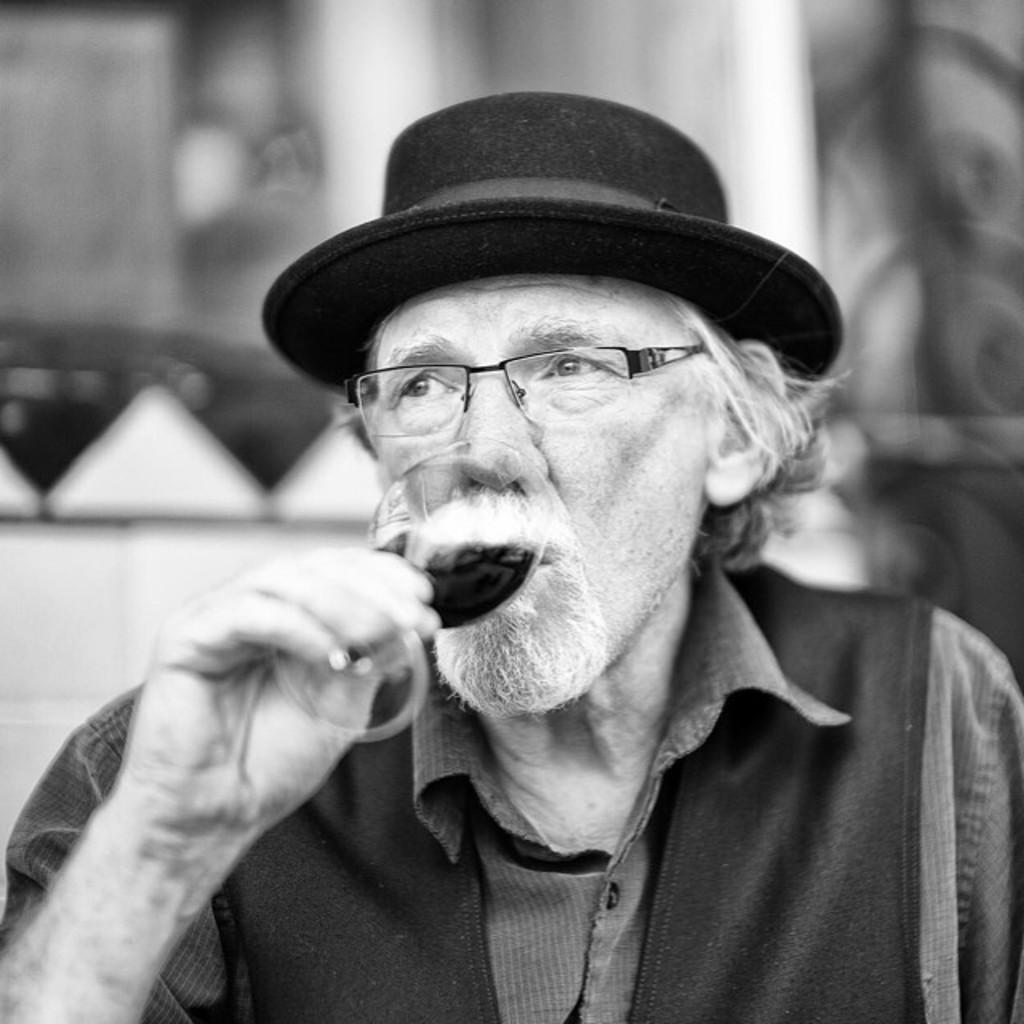Who is the main subject in the image? There is an old man in the center of the image. What is the old man wearing on his head? The old man is wearing a hat. What is the old man holding in his hand? The old man is holding a glass in his hand. Can you describe the background of the image? The background of the image is blurred. What type of glove is the old man wearing in the image? There is no glove present in the image; the old man is wearing a hat. Who is the owner of the snail in the image? There is no snail present in the image. 